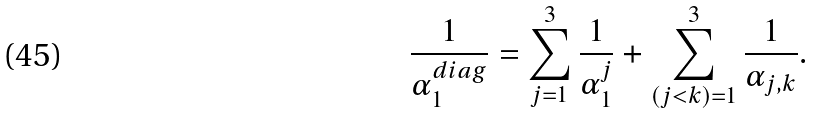Convert formula to latex. <formula><loc_0><loc_0><loc_500><loc_500>\frac { 1 } { \alpha _ { 1 } ^ { d i a g } } = \sum _ { j = 1 } ^ { 3 } \frac { 1 } { \alpha _ { 1 } ^ { j } } + \sum _ { ( j < k ) = 1 } ^ { 3 } \frac { 1 } { \alpha _ { j , k } } .</formula> 